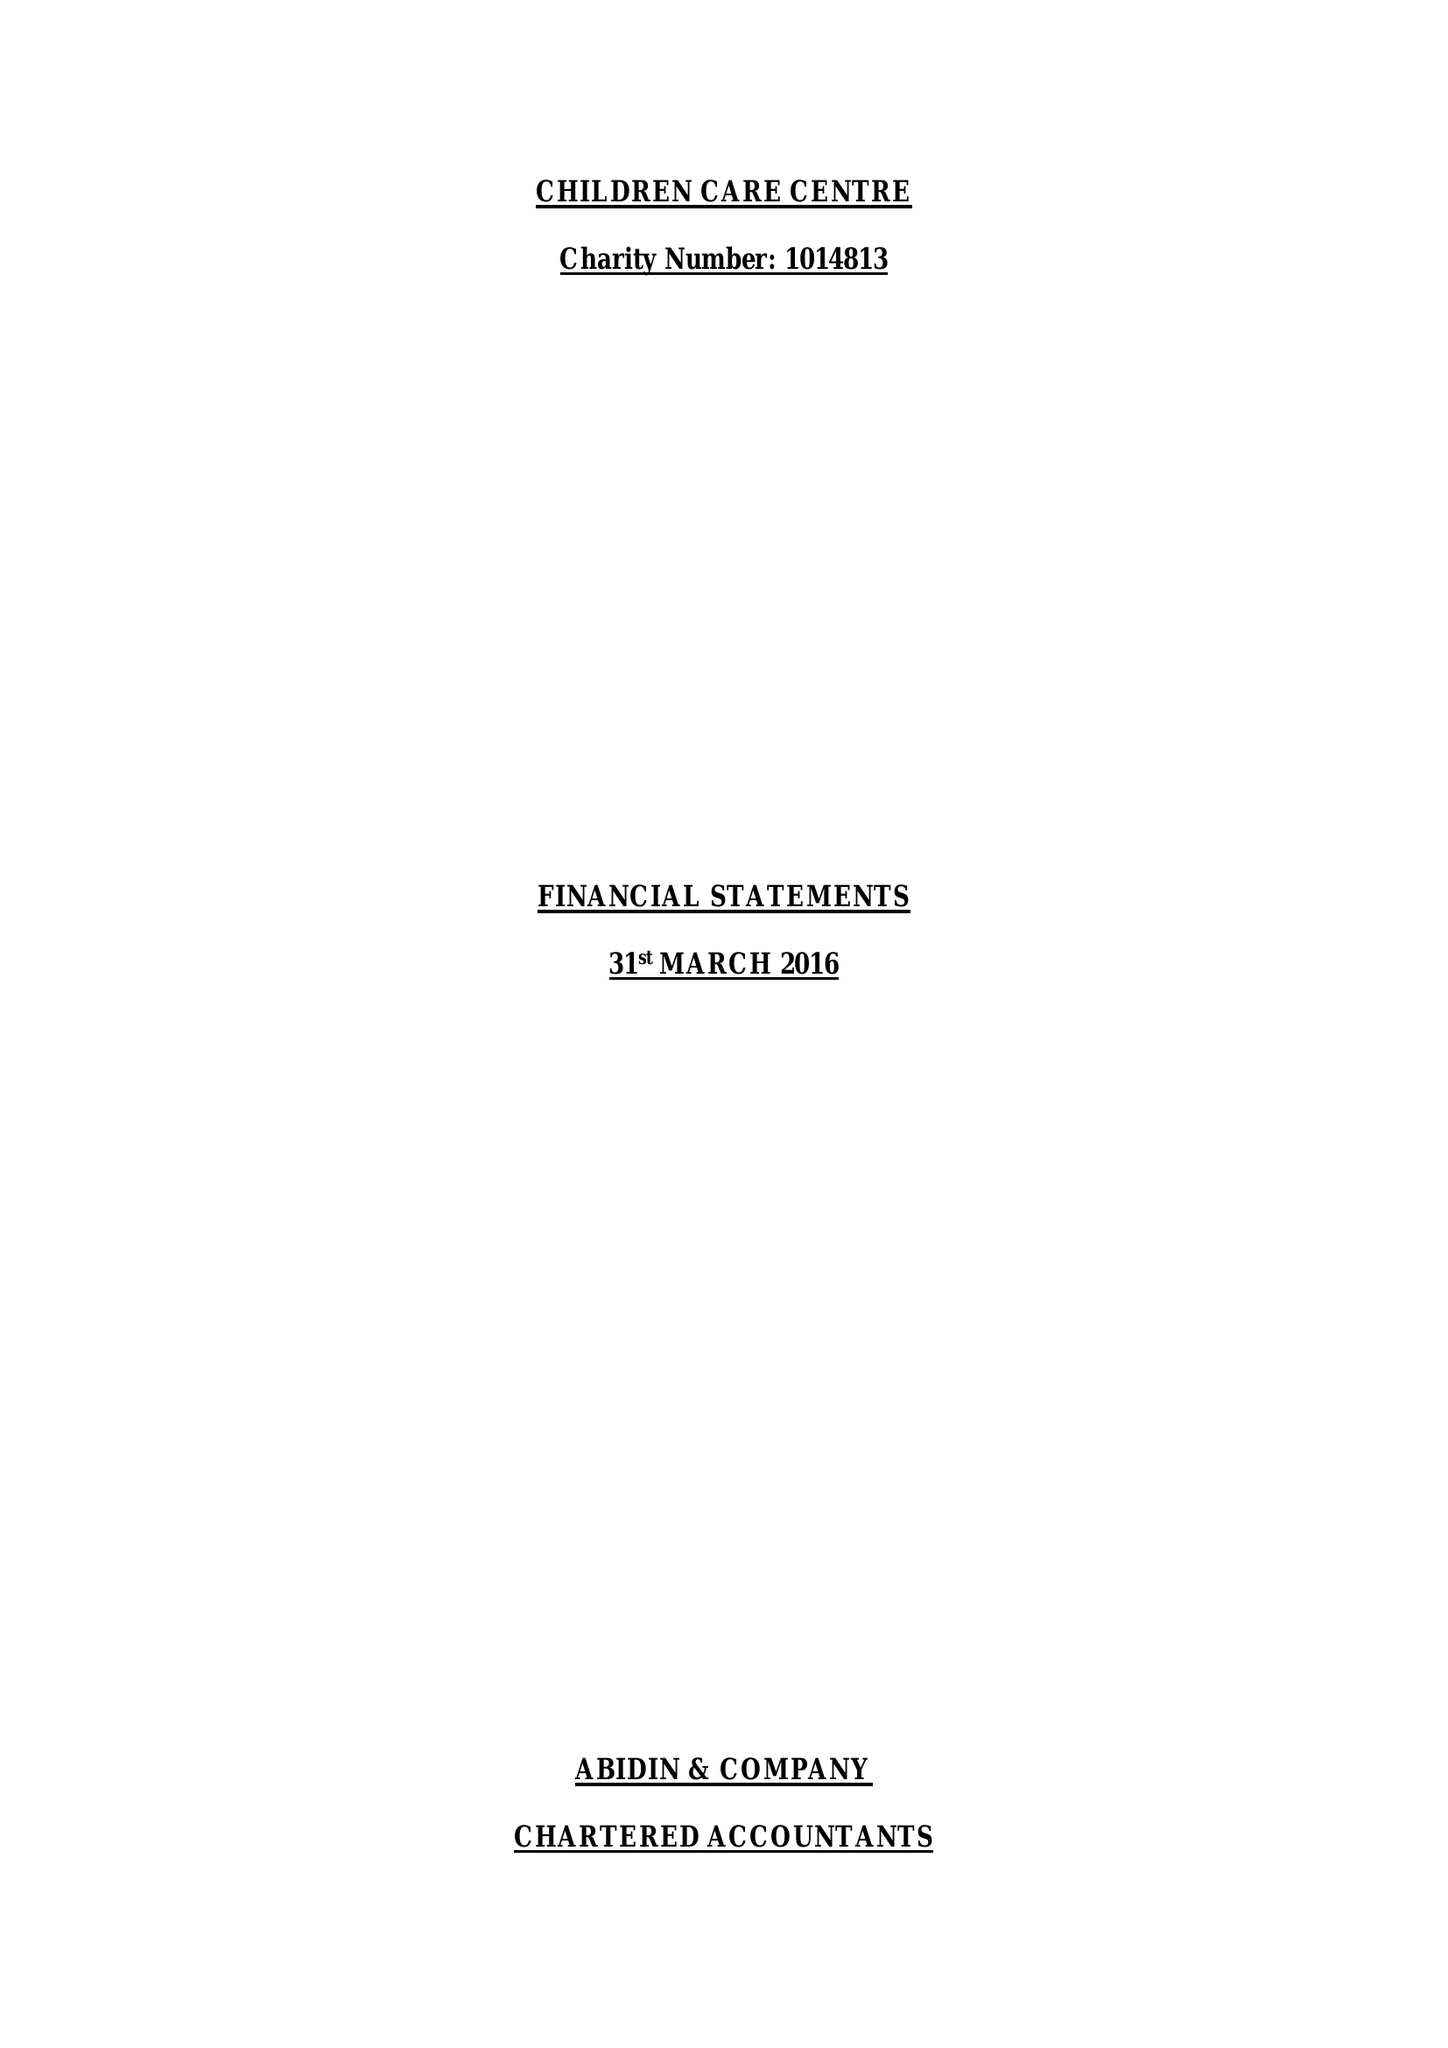What is the value for the address__street_line?
Answer the question using a single word or phrase. 86 HAMPTON ROAD 